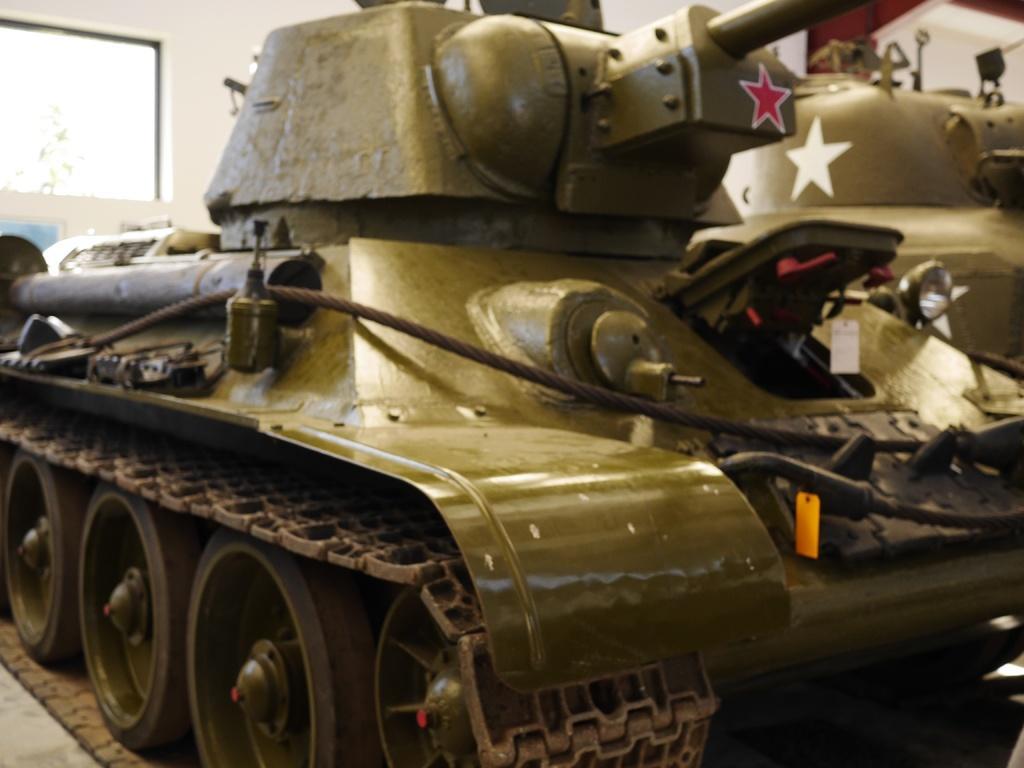Describe this image in one or two sentences. In this image I can see the tank. 